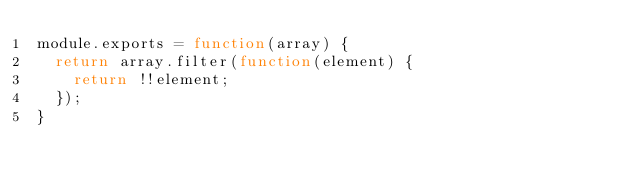<code> <loc_0><loc_0><loc_500><loc_500><_JavaScript_>module.exports = function(array) {
  return array.filter(function(element) {
    return !!element;
  });
}
</code> 